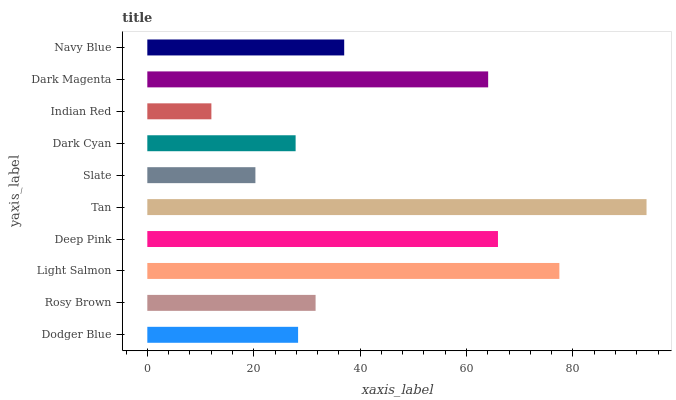Is Indian Red the minimum?
Answer yes or no. Yes. Is Tan the maximum?
Answer yes or no. Yes. Is Rosy Brown the minimum?
Answer yes or no. No. Is Rosy Brown the maximum?
Answer yes or no. No. Is Rosy Brown greater than Dodger Blue?
Answer yes or no. Yes. Is Dodger Blue less than Rosy Brown?
Answer yes or no. Yes. Is Dodger Blue greater than Rosy Brown?
Answer yes or no. No. Is Rosy Brown less than Dodger Blue?
Answer yes or no. No. Is Navy Blue the high median?
Answer yes or no. Yes. Is Rosy Brown the low median?
Answer yes or no. Yes. Is Indian Red the high median?
Answer yes or no. No. Is Indian Red the low median?
Answer yes or no. No. 